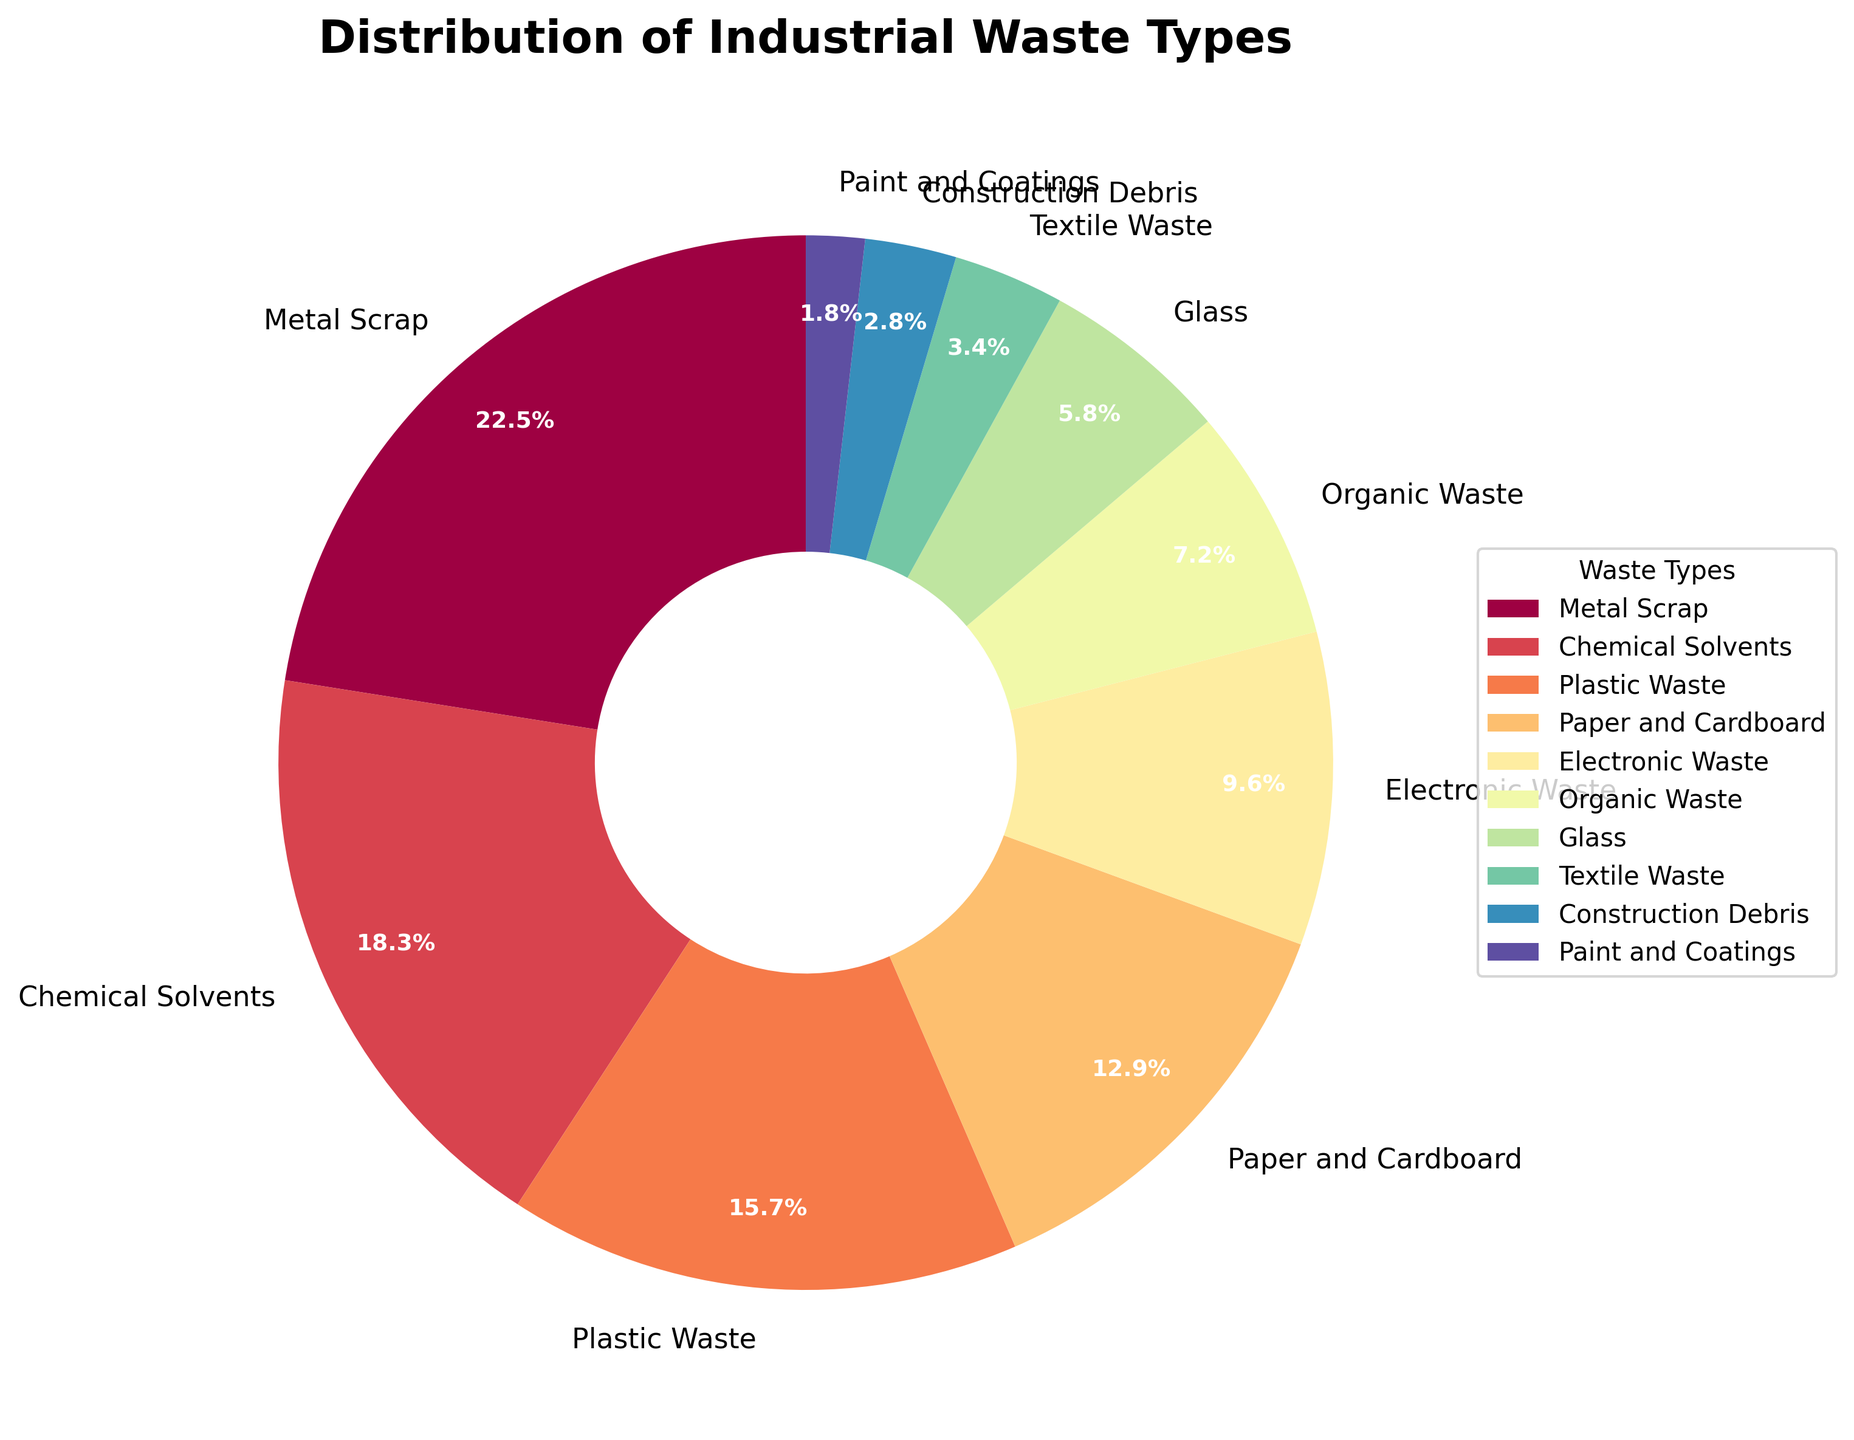What type of waste takes up the largest portion of the pie chart? Explanation: By visually examining the pie chart, we can see that the segment labeled "Metal Scrap" has the largest area. This indicates that Metal Scrap has the highest percentage of the distribution.
Answer: Metal Scrap What is the percentage difference between Metal Scrap and Chemical Solvents? Explanation: From the pie chart, we see that Metal Scrap constitutes 22.5% and Chemical Solvents constitute 18.3%. The difference is calculated by subtracting the smaller percentage from the larger one: 22.5% - 18.3% = 4.2%.
Answer: 4.2% Which waste type has a smaller percentage, Organic Waste or Glass? Explanation: Examining the pie chart, Organic Waste has a percentage of 7.2% and Glass has 5.8%. Since 5.8% is smaller than 7.2%, Glass has the smaller percentage.
Answer: Glass What is the combined percentage of Plastic Waste, Paper and Cardboard, and Electronic Waste? Explanation: From the pie chart, we note that Plastic Waste is 15.7%, Paper and Cardboard is 12.9%, and Electronic Waste is 9.6%. Adding these percentages gives 15.7% + 12.9% + 9.6% = 38.2%.
Answer: 38.2% Is the percentage of Textile Waste greater than or less than the percentage of Construction Debris? Explanation: According to the pie chart, Textile Waste is 3.4% and Construction Debris is 2.8%. Since 3.4% is greater than 2.8%, Textile Waste has a greater percentage.
Answer: Greater What is the total percentage of waste types that each have less than 5%? Explanation: From the pie chart, the waste types with percentages less than 5% are Textile Waste (3.4%), Construction Debris (2.8%), and Paint and Coatings (1.8%). Summing these percentages, we get 3.4% + 2.8% + 1.8% = 8.0%.
Answer: 8.0% Which waste type has the smallest portion on the pie chart? Explanation: Visually inspecting the pie chart, the segment for "Paint and Coatings" is the smallest in size, indicating it has the lowest percentage.
Answer: Paint and Coatings What is the percentage range of the waste types depicted in the pie chart? Explanation: By examining the pie chart, the largest percentage is 22.5% (Metal Scrap) and the smallest percentage is 1.8% (Paint and Coatings). The range is calculated as 22.5% - 1.8% = 20.7%.
Answer: 20.7% How many waste types have a percentage greater than 10%? Explanation: Referencing the pie chart, the waste types with percentages greater than 10% are Metal Scrap (22.5%), Chemical Solvents (18.3%), Plastic Waste (15.7%), and Paper and Cardboard (12.9%). Counting these gives a total of 4 types.
Answer: 4 